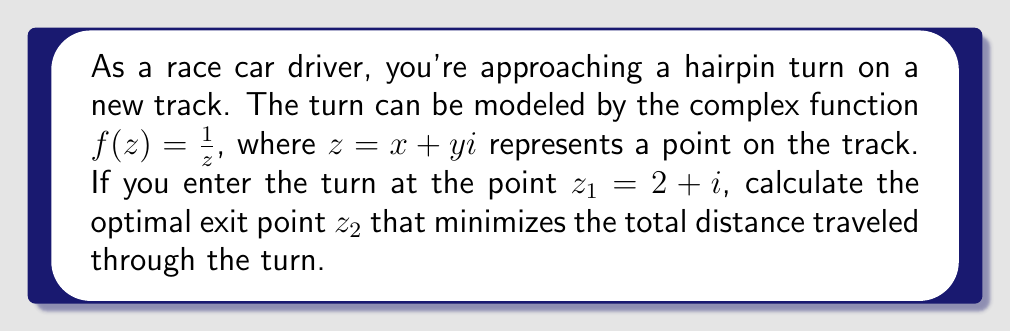Could you help me with this problem? Let's approach this step-by-step:

1) The optimal racing line through a hairpin turn modeled by $f(z) = \frac{1}{z}$ is a circular arc.

2) The center of this circular arc is the point that remains fixed under the transformation. To find it, we solve:

   $z = \frac{1}{z}$
   $z^2 = 1$
   $z = \pm 1$

   The center is at $z = 1$ (the positive real axis).

3) The radius of the circular arc is the distance from the center to the entry point:

   $r = |z_1 - 1| = |(2+i) - 1| = |1+i| = \sqrt{1^2 + 1^2} = \sqrt{2}$

4) The exit point $z_2$ will be the reflection of $z_1$ across the real axis:

   If $z_1 = a + bi$, then $z_2 = a - bi$

5) Therefore, $z_2 = 2 - i$

6) We can verify this:

   $f(z_1) = \frac{1}{2+i} = \frac{2-i}{5} = 0.4 - 0.2i$
   $f(z_2) = \frac{1}{2-i} = \frac{2+i}{5} = 0.4 + 0.2i$

   These are indeed reflections of each other across the real axis.

[asy]
import geometry;

unitsize(1cm);

pair z1 = (2,1);
pair z2 = (2,-1);
pair center = (1,0);

draw(circle(center, sqrt(2)));
draw((0,0)--(3,0), arrow=Arrow(TeXHead));
draw((0,-2)--(0,2), arrow=Arrow(TeXHead));

dot(z1);
dot(z2);
dot(center);

label("$z_1$", z1, NE);
label("$z_2$", z2, SE);
label("1", center, SW);

draw(z1--center--z2, dashed);
[/asy]
Answer: $z_2 = 2 - i$ 